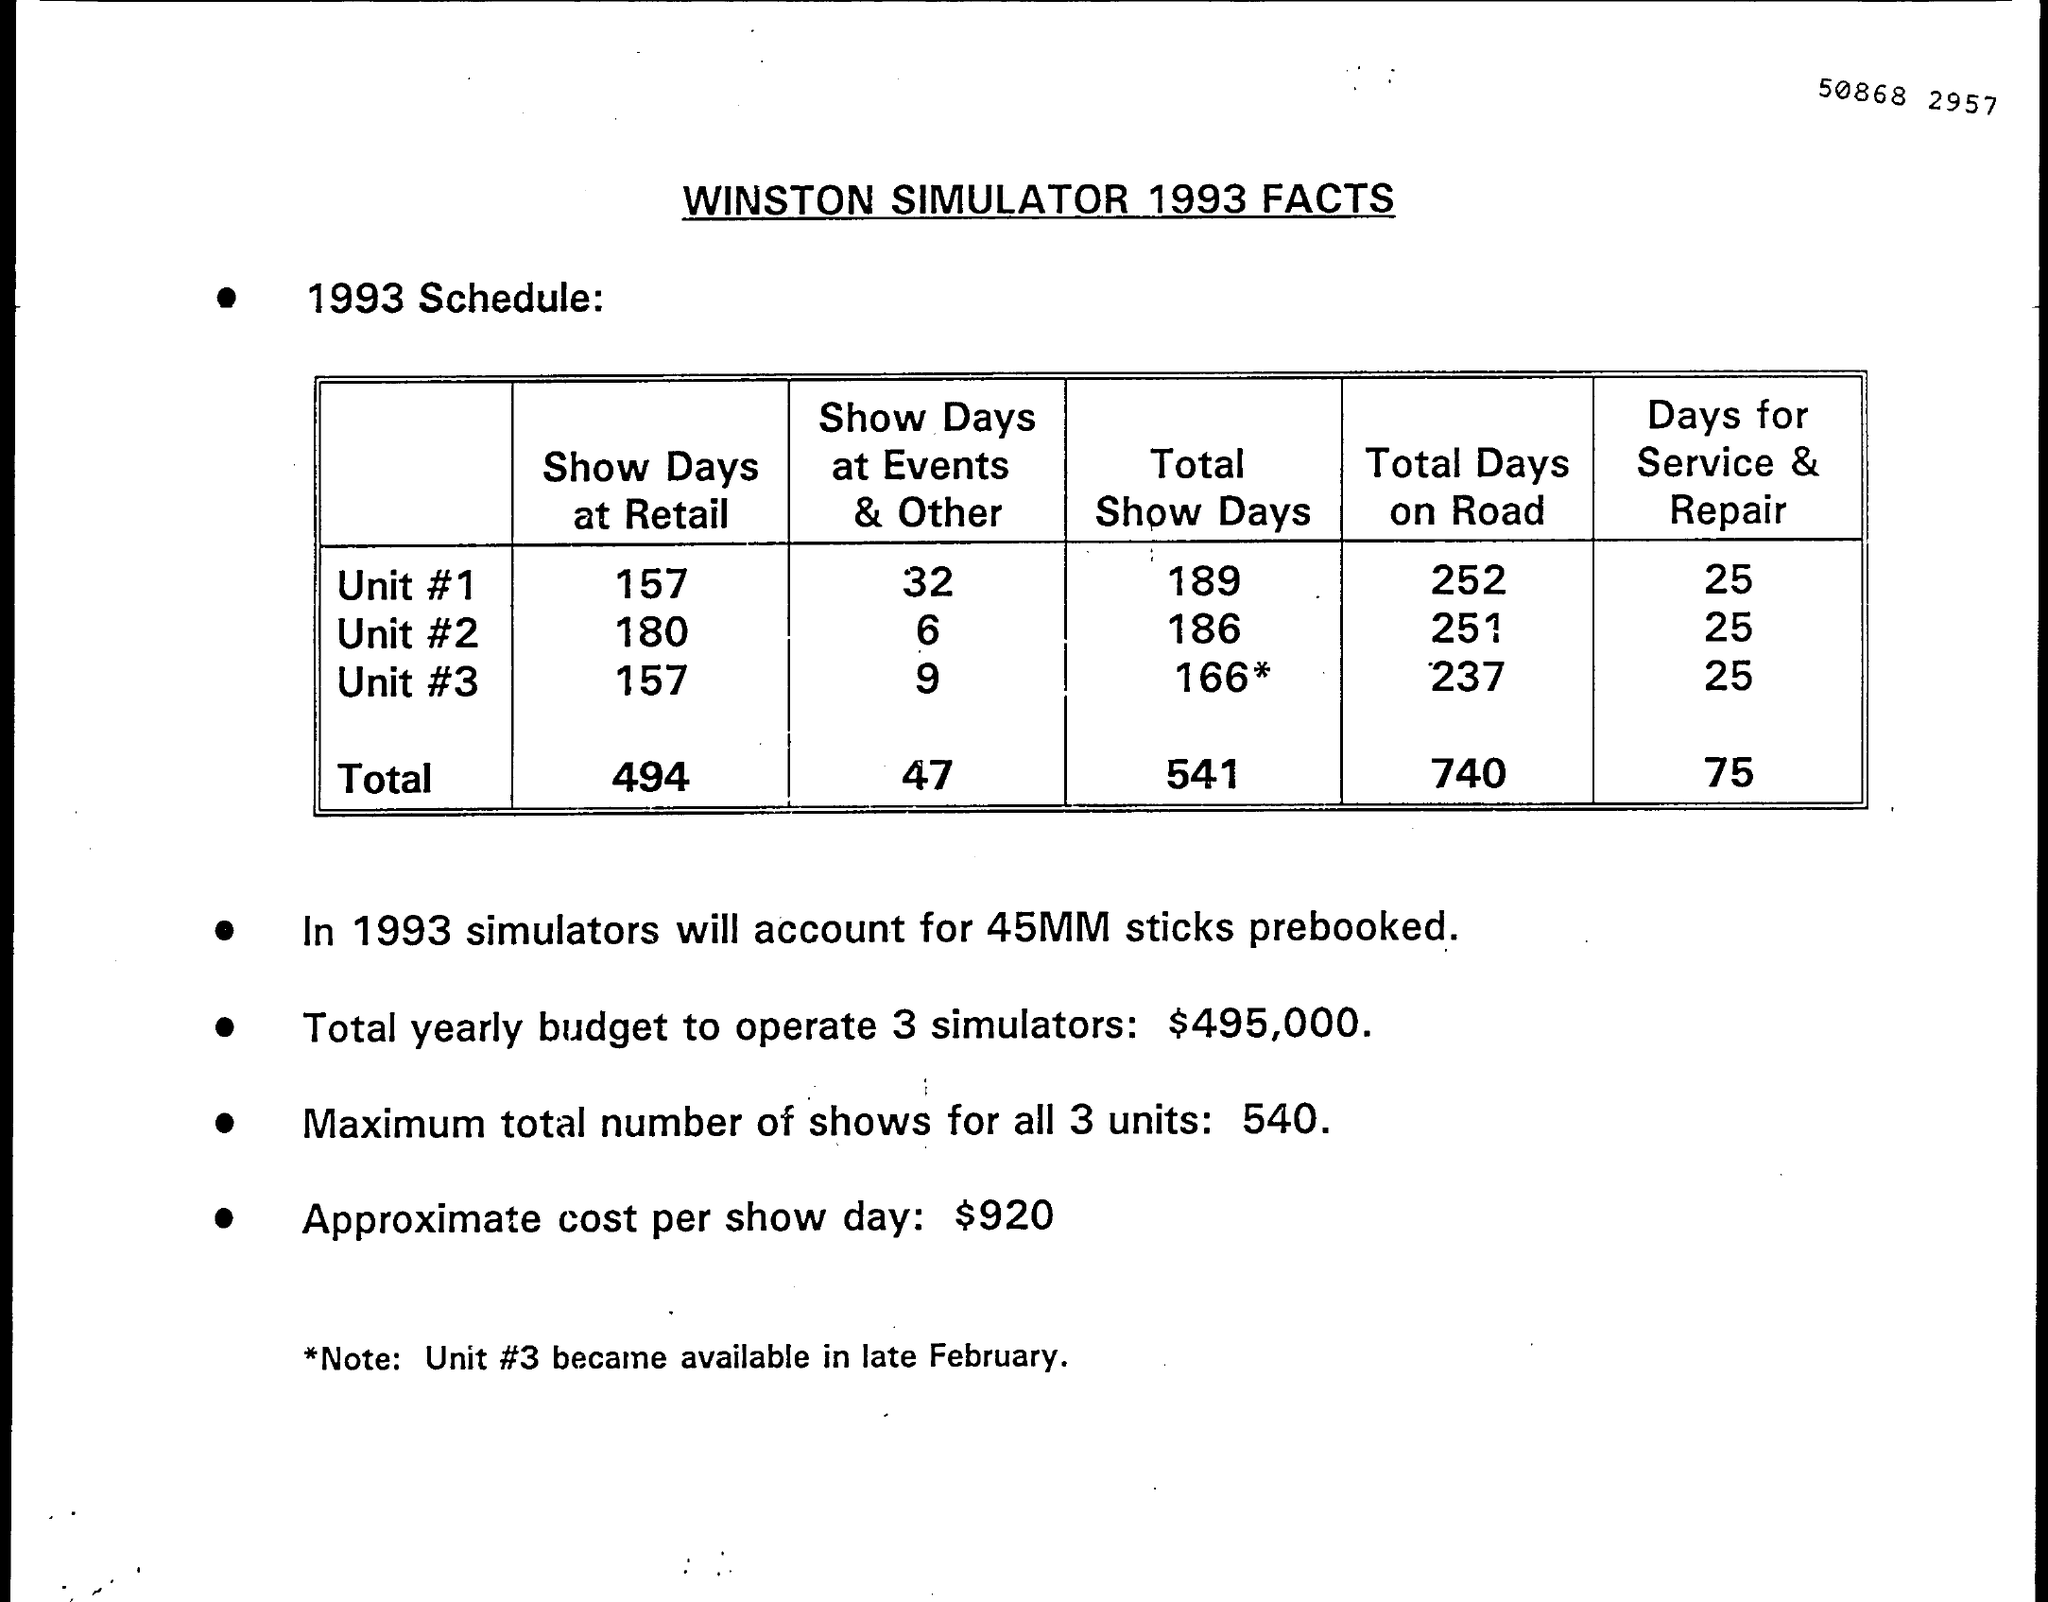What is the Title of the document ?
Give a very brief answer. WINSTON SIMULATOR 1993 FACTS. What is the Approximate cost per show Day?
Offer a terse response. $920. In Unit # 1 how many days for Service & Repair ?
Your response must be concise. 25. How many sticks prebooked ?
Offer a very short reply. 45MM sticks. How much total yearly budget to operate 3 simulators ?
Keep it short and to the point. $495,000. What is written in the Note Field ?
Offer a terse response. Unit #3 became available in late February. 